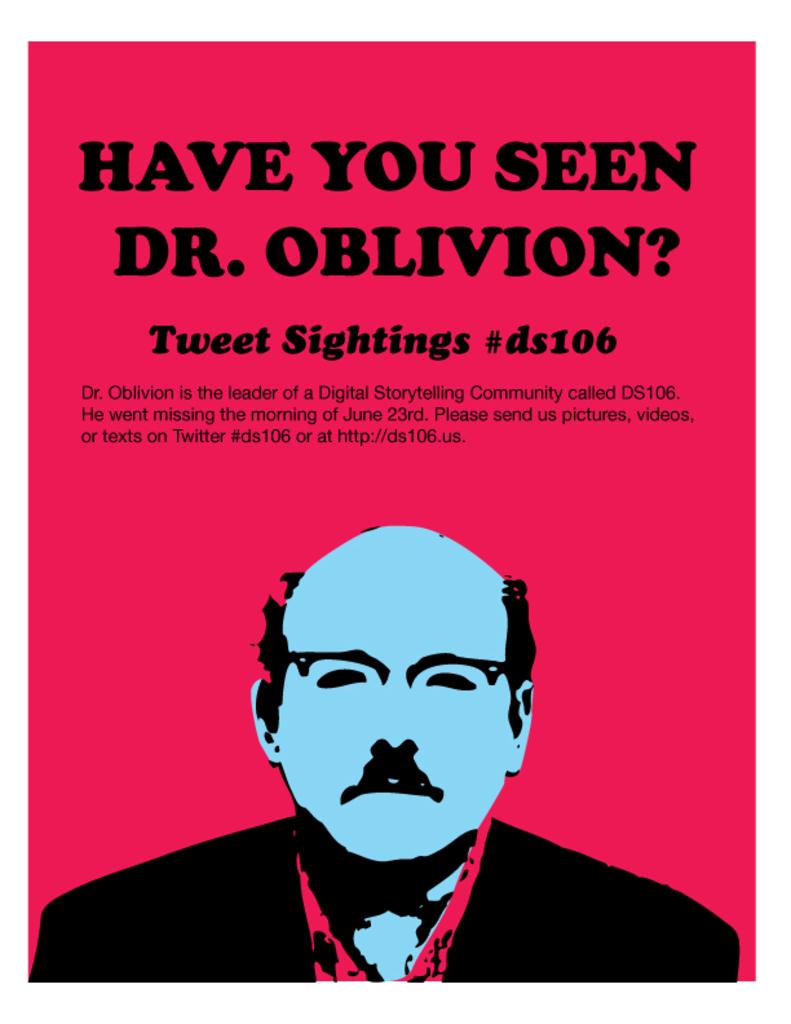What is the name of the doctor on the title of this poster?
Provide a short and direct response. Dr. oblivion. What is the name of the digital storytelling community?
Make the answer very short. Ds106. 